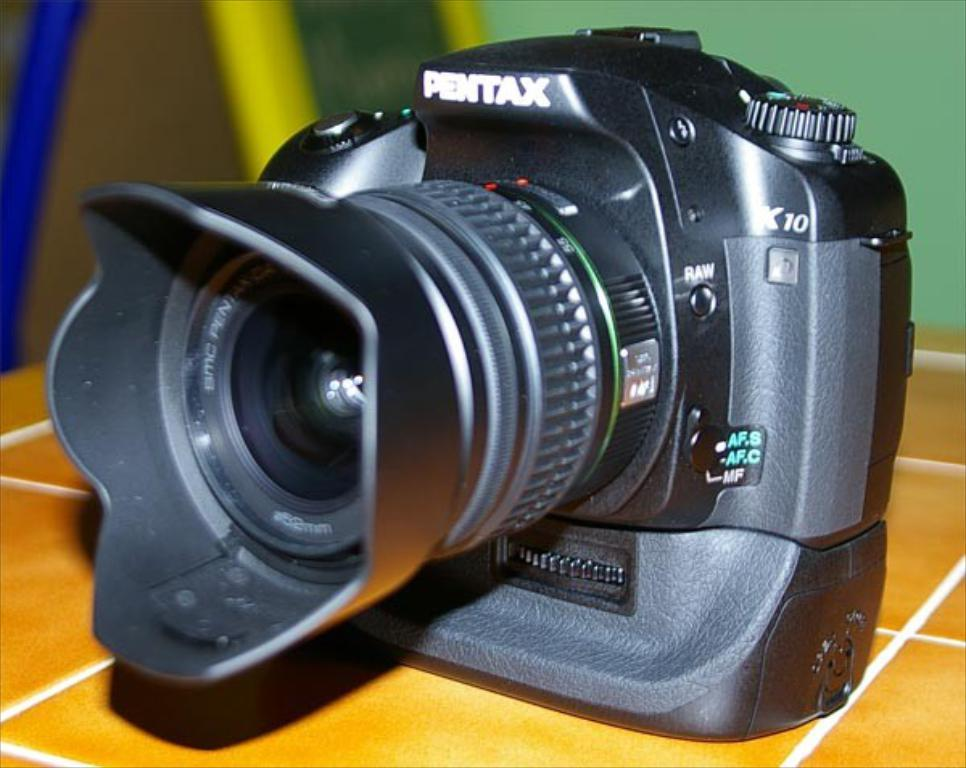What is the main object in the image? There is a camera with a lens in the image. What is the surface on which the camera is placed? The camera is placed on a tile surface. Can you describe the background of the image? The background of the image is blurred. What type of stamp can be seen on the camera in the image? There is no stamp present on the camera in the image. How many days are depicted in the advertisement in the image? There is no advertisement present in the image. 